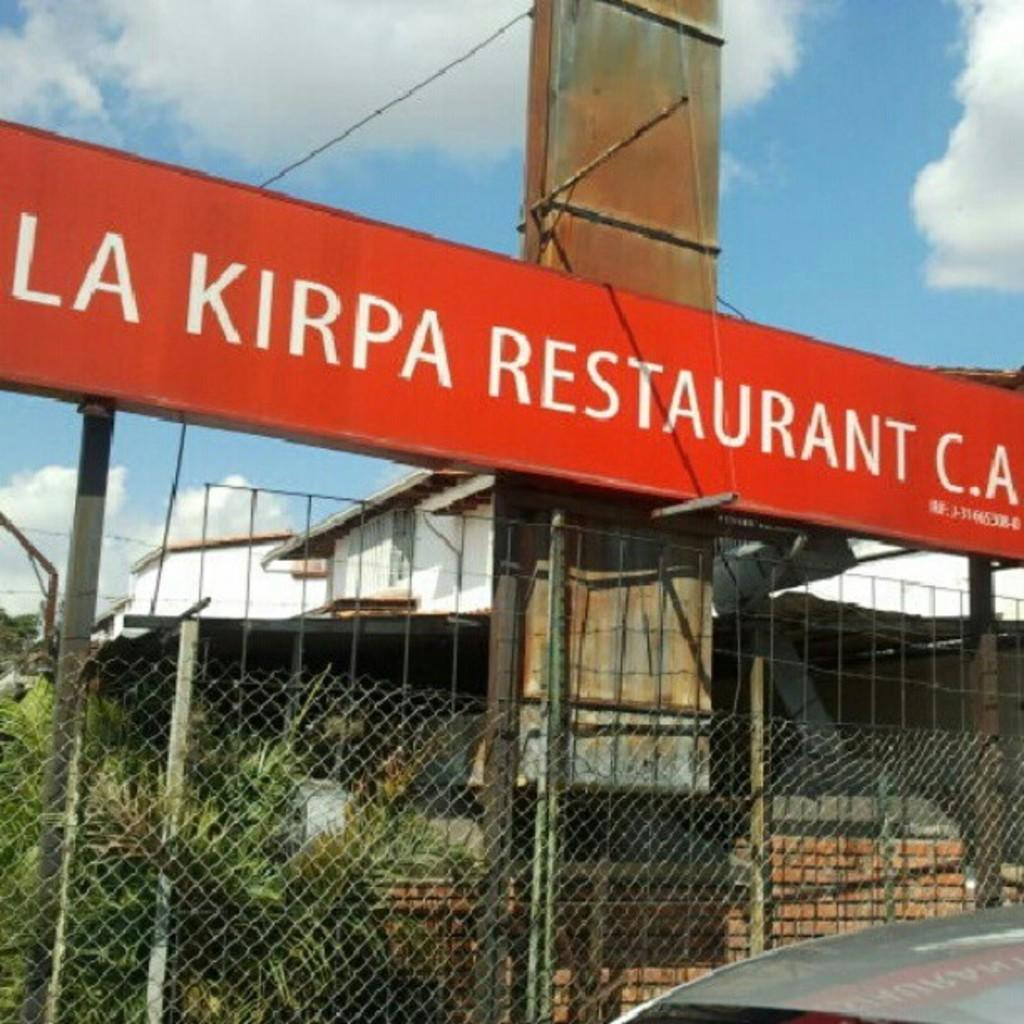What type of structure is visible in the image? There is a house in the image. What is located near the house? There is a fence in the image. What type of vegetation can be seen in the image? There are plants and trees in the image. What mode of transportation is present in the image? There is a vehicle in the image. What is the message or information displayed in the image? There is a board with text in the image. How would you describe the weather in the image? The sky is cloudy in the image. What type of sheet is covering the minister in the image? There is no minister or sheet present in the image. What type of school is visible in the image? There is no school present in the image. 